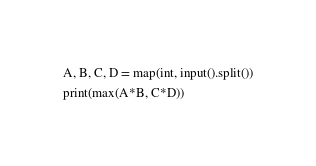<code> <loc_0><loc_0><loc_500><loc_500><_Python_>A, B, C, D = map(int, input().split())
print(max(A*B, C*D))</code> 